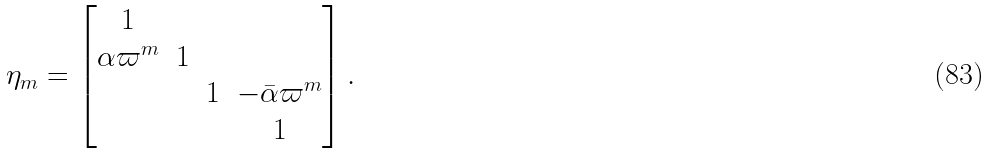Convert formula to latex. <formula><loc_0><loc_0><loc_500><loc_500>\eta _ { m } = \begin{bmatrix} 1 \\ \alpha \varpi ^ { m } & 1 \\ & & 1 & - \bar { \alpha } \varpi ^ { m } \\ & & & 1 \end{bmatrix} .</formula> 